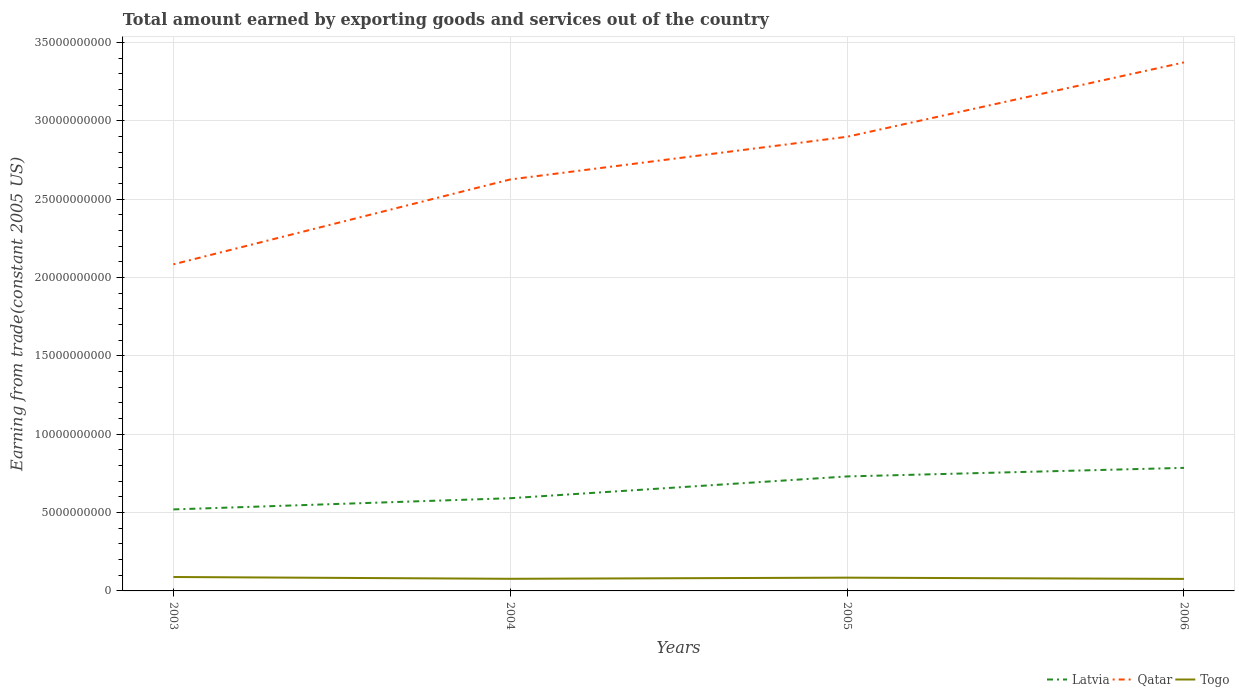Across all years, what is the maximum total amount earned by exporting goods and services in Qatar?
Your response must be concise. 2.08e+1. In which year was the total amount earned by exporting goods and services in Latvia maximum?
Your answer should be very brief. 2003. What is the total total amount earned by exporting goods and services in Qatar in the graph?
Your answer should be very brief. -4.75e+09. What is the difference between the highest and the second highest total amount earned by exporting goods and services in Qatar?
Offer a very short reply. 1.29e+1. What is the difference between the highest and the lowest total amount earned by exporting goods and services in Latvia?
Offer a very short reply. 2. How many lines are there?
Make the answer very short. 3. How many years are there in the graph?
Keep it short and to the point. 4. What is the difference between two consecutive major ticks on the Y-axis?
Make the answer very short. 5.00e+09. Does the graph contain any zero values?
Your answer should be compact. No. Where does the legend appear in the graph?
Make the answer very short. Bottom right. What is the title of the graph?
Provide a succinct answer. Total amount earned by exporting goods and services out of the country. What is the label or title of the Y-axis?
Offer a very short reply. Earning from trade(constant 2005 US). What is the Earning from trade(constant 2005 US) in Latvia in 2003?
Offer a terse response. 5.20e+09. What is the Earning from trade(constant 2005 US) in Qatar in 2003?
Offer a terse response. 2.08e+1. What is the Earning from trade(constant 2005 US) in Togo in 2003?
Provide a short and direct response. 8.88e+08. What is the Earning from trade(constant 2005 US) in Latvia in 2004?
Provide a short and direct response. 5.92e+09. What is the Earning from trade(constant 2005 US) in Qatar in 2004?
Keep it short and to the point. 2.63e+1. What is the Earning from trade(constant 2005 US) in Togo in 2004?
Offer a very short reply. 7.74e+08. What is the Earning from trade(constant 2005 US) of Latvia in 2005?
Your answer should be compact. 7.31e+09. What is the Earning from trade(constant 2005 US) in Qatar in 2005?
Ensure brevity in your answer.  2.90e+1. What is the Earning from trade(constant 2005 US) of Togo in 2005?
Offer a terse response. 8.47e+08. What is the Earning from trade(constant 2005 US) in Latvia in 2006?
Offer a very short reply. 7.85e+09. What is the Earning from trade(constant 2005 US) in Qatar in 2006?
Make the answer very short. 3.37e+1. What is the Earning from trade(constant 2005 US) of Togo in 2006?
Your response must be concise. 7.66e+08. Across all years, what is the maximum Earning from trade(constant 2005 US) in Latvia?
Ensure brevity in your answer.  7.85e+09. Across all years, what is the maximum Earning from trade(constant 2005 US) in Qatar?
Give a very brief answer. 3.37e+1. Across all years, what is the maximum Earning from trade(constant 2005 US) of Togo?
Provide a short and direct response. 8.88e+08. Across all years, what is the minimum Earning from trade(constant 2005 US) of Latvia?
Offer a very short reply. 5.20e+09. Across all years, what is the minimum Earning from trade(constant 2005 US) of Qatar?
Your answer should be compact. 2.08e+1. Across all years, what is the minimum Earning from trade(constant 2005 US) of Togo?
Make the answer very short. 7.66e+08. What is the total Earning from trade(constant 2005 US) in Latvia in the graph?
Offer a terse response. 2.63e+1. What is the total Earning from trade(constant 2005 US) in Qatar in the graph?
Keep it short and to the point. 1.10e+11. What is the total Earning from trade(constant 2005 US) in Togo in the graph?
Make the answer very short. 3.28e+09. What is the difference between the Earning from trade(constant 2005 US) of Latvia in 2003 and that in 2004?
Keep it short and to the point. -7.14e+08. What is the difference between the Earning from trade(constant 2005 US) in Qatar in 2003 and that in 2004?
Your answer should be compact. -5.42e+09. What is the difference between the Earning from trade(constant 2005 US) in Togo in 2003 and that in 2004?
Your answer should be very brief. 1.14e+08. What is the difference between the Earning from trade(constant 2005 US) of Latvia in 2003 and that in 2005?
Give a very brief answer. -2.10e+09. What is the difference between the Earning from trade(constant 2005 US) in Qatar in 2003 and that in 2005?
Provide a short and direct response. -8.14e+09. What is the difference between the Earning from trade(constant 2005 US) in Togo in 2003 and that in 2005?
Offer a very short reply. 4.11e+07. What is the difference between the Earning from trade(constant 2005 US) of Latvia in 2003 and that in 2006?
Your response must be concise. -2.65e+09. What is the difference between the Earning from trade(constant 2005 US) in Qatar in 2003 and that in 2006?
Make the answer very short. -1.29e+1. What is the difference between the Earning from trade(constant 2005 US) in Togo in 2003 and that in 2006?
Give a very brief answer. 1.22e+08. What is the difference between the Earning from trade(constant 2005 US) in Latvia in 2004 and that in 2005?
Make the answer very short. -1.39e+09. What is the difference between the Earning from trade(constant 2005 US) in Qatar in 2004 and that in 2005?
Keep it short and to the point. -2.72e+09. What is the difference between the Earning from trade(constant 2005 US) in Togo in 2004 and that in 2005?
Give a very brief answer. -7.28e+07. What is the difference between the Earning from trade(constant 2005 US) in Latvia in 2004 and that in 2006?
Your answer should be compact. -1.94e+09. What is the difference between the Earning from trade(constant 2005 US) of Qatar in 2004 and that in 2006?
Give a very brief answer. -7.47e+09. What is the difference between the Earning from trade(constant 2005 US) of Togo in 2004 and that in 2006?
Ensure brevity in your answer.  7.80e+06. What is the difference between the Earning from trade(constant 2005 US) in Latvia in 2005 and that in 2006?
Give a very brief answer. -5.47e+08. What is the difference between the Earning from trade(constant 2005 US) of Qatar in 2005 and that in 2006?
Offer a very short reply. -4.75e+09. What is the difference between the Earning from trade(constant 2005 US) of Togo in 2005 and that in 2006?
Offer a terse response. 8.07e+07. What is the difference between the Earning from trade(constant 2005 US) of Latvia in 2003 and the Earning from trade(constant 2005 US) of Qatar in 2004?
Make the answer very short. -2.11e+1. What is the difference between the Earning from trade(constant 2005 US) of Latvia in 2003 and the Earning from trade(constant 2005 US) of Togo in 2004?
Offer a very short reply. 4.43e+09. What is the difference between the Earning from trade(constant 2005 US) of Qatar in 2003 and the Earning from trade(constant 2005 US) of Togo in 2004?
Your answer should be very brief. 2.01e+1. What is the difference between the Earning from trade(constant 2005 US) of Latvia in 2003 and the Earning from trade(constant 2005 US) of Qatar in 2005?
Provide a succinct answer. -2.38e+1. What is the difference between the Earning from trade(constant 2005 US) in Latvia in 2003 and the Earning from trade(constant 2005 US) in Togo in 2005?
Provide a succinct answer. 4.35e+09. What is the difference between the Earning from trade(constant 2005 US) in Qatar in 2003 and the Earning from trade(constant 2005 US) in Togo in 2005?
Your response must be concise. 2.00e+1. What is the difference between the Earning from trade(constant 2005 US) in Latvia in 2003 and the Earning from trade(constant 2005 US) in Qatar in 2006?
Provide a succinct answer. -2.85e+1. What is the difference between the Earning from trade(constant 2005 US) in Latvia in 2003 and the Earning from trade(constant 2005 US) in Togo in 2006?
Offer a terse response. 4.44e+09. What is the difference between the Earning from trade(constant 2005 US) of Qatar in 2003 and the Earning from trade(constant 2005 US) of Togo in 2006?
Give a very brief answer. 2.01e+1. What is the difference between the Earning from trade(constant 2005 US) in Latvia in 2004 and the Earning from trade(constant 2005 US) in Qatar in 2005?
Give a very brief answer. -2.31e+1. What is the difference between the Earning from trade(constant 2005 US) of Latvia in 2004 and the Earning from trade(constant 2005 US) of Togo in 2005?
Keep it short and to the point. 5.07e+09. What is the difference between the Earning from trade(constant 2005 US) in Qatar in 2004 and the Earning from trade(constant 2005 US) in Togo in 2005?
Give a very brief answer. 2.54e+1. What is the difference between the Earning from trade(constant 2005 US) in Latvia in 2004 and the Earning from trade(constant 2005 US) in Qatar in 2006?
Your answer should be compact. -2.78e+1. What is the difference between the Earning from trade(constant 2005 US) in Latvia in 2004 and the Earning from trade(constant 2005 US) in Togo in 2006?
Your response must be concise. 5.15e+09. What is the difference between the Earning from trade(constant 2005 US) in Qatar in 2004 and the Earning from trade(constant 2005 US) in Togo in 2006?
Your answer should be very brief. 2.55e+1. What is the difference between the Earning from trade(constant 2005 US) in Latvia in 2005 and the Earning from trade(constant 2005 US) in Qatar in 2006?
Offer a very short reply. -2.64e+1. What is the difference between the Earning from trade(constant 2005 US) in Latvia in 2005 and the Earning from trade(constant 2005 US) in Togo in 2006?
Make the answer very short. 6.54e+09. What is the difference between the Earning from trade(constant 2005 US) of Qatar in 2005 and the Earning from trade(constant 2005 US) of Togo in 2006?
Your answer should be compact. 2.82e+1. What is the average Earning from trade(constant 2005 US) of Latvia per year?
Your answer should be compact. 6.57e+09. What is the average Earning from trade(constant 2005 US) in Qatar per year?
Your response must be concise. 2.75e+1. What is the average Earning from trade(constant 2005 US) in Togo per year?
Offer a very short reply. 8.19e+08. In the year 2003, what is the difference between the Earning from trade(constant 2005 US) in Latvia and Earning from trade(constant 2005 US) in Qatar?
Give a very brief answer. -1.56e+1. In the year 2003, what is the difference between the Earning from trade(constant 2005 US) in Latvia and Earning from trade(constant 2005 US) in Togo?
Offer a very short reply. 4.31e+09. In the year 2003, what is the difference between the Earning from trade(constant 2005 US) in Qatar and Earning from trade(constant 2005 US) in Togo?
Keep it short and to the point. 2.00e+1. In the year 2004, what is the difference between the Earning from trade(constant 2005 US) of Latvia and Earning from trade(constant 2005 US) of Qatar?
Offer a very short reply. -2.03e+1. In the year 2004, what is the difference between the Earning from trade(constant 2005 US) of Latvia and Earning from trade(constant 2005 US) of Togo?
Provide a succinct answer. 5.14e+09. In the year 2004, what is the difference between the Earning from trade(constant 2005 US) in Qatar and Earning from trade(constant 2005 US) in Togo?
Make the answer very short. 2.55e+1. In the year 2005, what is the difference between the Earning from trade(constant 2005 US) of Latvia and Earning from trade(constant 2005 US) of Qatar?
Your answer should be compact. -2.17e+1. In the year 2005, what is the difference between the Earning from trade(constant 2005 US) of Latvia and Earning from trade(constant 2005 US) of Togo?
Provide a short and direct response. 6.46e+09. In the year 2005, what is the difference between the Earning from trade(constant 2005 US) in Qatar and Earning from trade(constant 2005 US) in Togo?
Your response must be concise. 2.81e+1. In the year 2006, what is the difference between the Earning from trade(constant 2005 US) in Latvia and Earning from trade(constant 2005 US) in Qatar?
Keep it short and to the point. -2.59e+1. In the year 2006, what is the difference between the Earning from trade(constant 2005 US) in Latvia and Earning from trade(constant 2005 US) in Togo?
Provide a short and direct response. 7.09e+09. In the year 2006, what is the difference between the Earning from trade(constant 2005 US) in Qatar and Earning from trade(constant 2005 US) in Togo?
Make the answer very short. 3.30e+1. What is the ratio of the Earning from trade(constant 2005 US) of Latvia in 2003 to that in 2004?
Provide a succinct answer. 0.88. What is the ratio of the Earning from trade(constant 2005 US) of Qatar in 2003 to that in 2004?
Offer a terse response. 0.79. What is the ratio of the Earning from trade(constant 2005 US) in Togo in 2003 to that in 2004?
Offer a terse response. 1.15. What is the ratio of the Earning from trade(constant 2005 US) of Latvia in 2003 to that in 2005?
Give a very brief answer. 0.71. What is the ratio of the Earning from trade(constant 2005 US) of Qatar in 2003 to that in 2005?
Your answer should be compact. 0.72. What is the ratio of the Earning from trade(constant 2005 US) of Togo in 2003 to that in 2005?
Provide a short and direct response. 1.05. What is the ratio of the Earning from trade(constant 2005 US) in Latvia in 2003 to that in 2006?
Keep it short and to the point. 0.66. What is the ratio of the Earning from trade(constant 2005 US) in Qatar in 2003 to that in 2006?
Keep it short and to the point. 0.62. What is the ratio of the Earning from trade(constant 2005 US) of Togo in 2003 to that in 2006?
Your response must be concise. 1.16. What is the ratio of the Earning from trade(constant 2005 US) of Latvia in 2004 to that in 2005?
Provide a succinct answer. 0.81. What is the ratio of the Earning from trade(constant 2005 US) of Qatar in 2004 to that in 2005?
Give a very brief answer. 0.91. What is the ratio of the Earning from trade(constant 2005 US) in Togo in 2004 to that in 2005?
Provide a succinct answer. 0.91. What is the ratio of the Earning from trade(constant 2005 US) of Latvia in 2004 to that in 2006?
Your answer should be very brief. 0.75. What is the ratio of the Earning from trade(constant 2005 US) of Qatar in 2004 to that in 2006?
Your answer should be compact. 0.78. What is the ratio of the Earning from trade(constant 2005 US) of Togo in 2004 to that in 2006?
Your response must be concise. 1.01. What is the ratio of the Earning from trade(constant 2005 US) of Latvia in 2005 to that in 2006?
Ensure brevity in your answer.  0.93. What is the ratio of the Earning from trade(constant 2005 US) of Qatar in 2005 to that in 2006?
Give a very brief answer. 0.86. What is the ratio of the Earning from trade(constant 2005 US) of Togo in 2005 to that in 2006?
Your answer should be compact. 1.11. What is the difference between the highest and the second highest Earning from trade(constant 2005 US) of Latvia?
Give a very brief answer. 5.47e+08. What is the difference between the highest and the second highest Earning from trade(constant 2005 US) of Qatar?
Ensure brevity in your answer.  4.75e+09. What is the difference between the highest and the second highest Earning from trade(constant 2005 US) in Togo?
Give a very brief answer. 4.11e+07. What is the difference between the highest and the lowest Earning from trade(constant 2005 US) of Latvia?
Provide a short and direct response. 2.65e+09. What is the difference between the highest and the lowest Earning from trade(constant 2005 US) in Qatar?
Ensure brevity in your answer.  1.29e+1. What is the difference between the highest and the lowest Earning from trade(constant 2005 US) of Togo?
Give a very brief answer. 1.22e+08. 